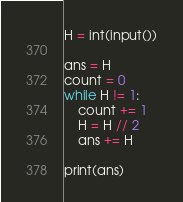Convert code to text. <code><loc_0><loc_0><loc_500><loc_500><_Python_>H = int(input())

ans = H
count = 0
while H != 1:
    count += 1
    H = H // 2
    ans += H

print(ans)</code> 